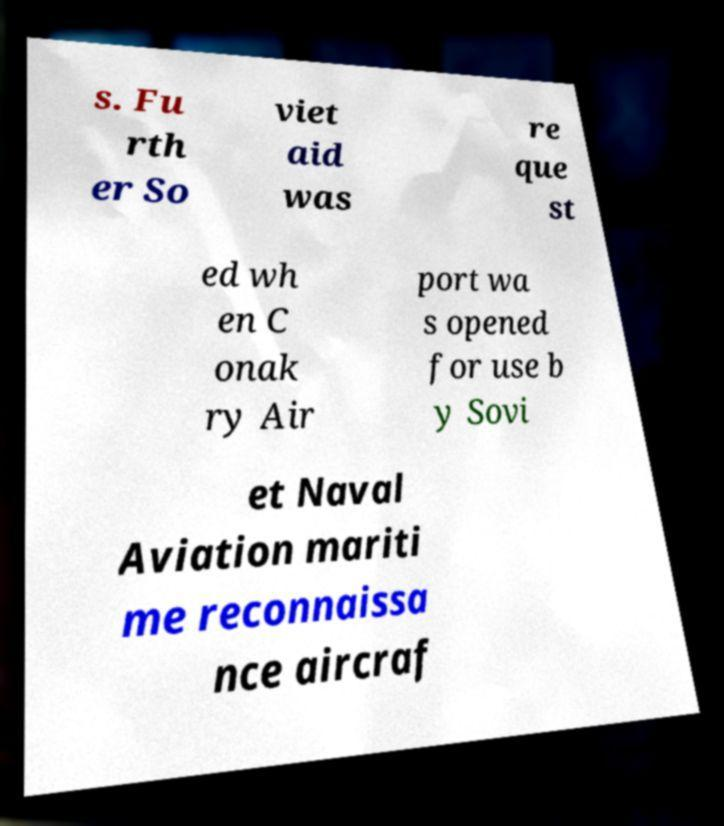Please identify and transcribe the text found in this image. s. Fu rth er So viet aid was re que st ed wh en C onak ry Air port wa s opened for use b y Sovi et Naval Aviation mariti me reconnaissa nce aircraf 